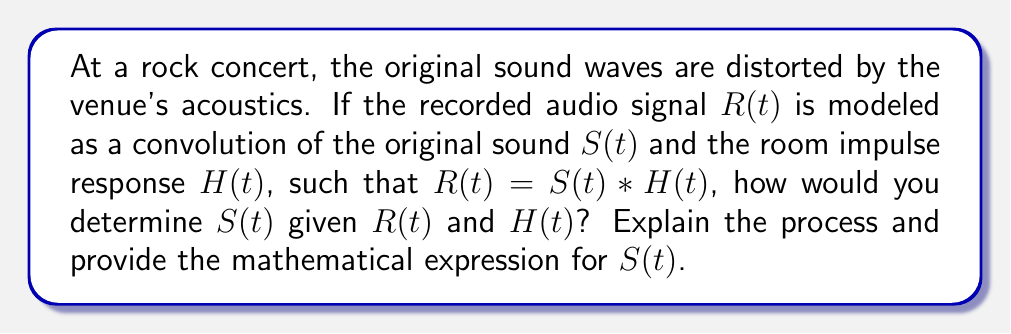Help me with this question. To determine the original sound waves $S(t)$ from the recorded audio $R(t)$ and the known room impulse response $H(t)$, we need to perform deconvolution. This is a classic inverse problem in audio processing. Here's a step-by-step approach:

1. First, recall that convolution in the time domain is equivalent to multiplication in the frequency domain. Let's apply the Fourier Transform to both sides of the equation:

   $$\mathcal{F}\{R(t)\} = \mathcal{F}\{S(t) * H(t)\} = \mathcal{F}\{S(t)\} \cdot \mathcal{F}\{H(t)\}$$

2. Let's denote the Fourier Transforms as:
   
   $$R(\omega) = S(\omega) \cdot H(\omega)$$

   where $\omega$ represents frequency.

3. To isolate $S(\omega)$, we can divide both sides by $H(\omega)$:

   $$S(\omega) = \frac{R(\omega)}{H(\omega)}$$

4. However, this direct division can lead to instabilities if $H(\omega)$ is close to zero at any frequencies. To mitigate this, we can use regularization techniques such as the Wiener deconvolution:

   $$S(\omega) = \frac{H^*(\omega)R(\omega)}{|H(\omega)|^2 + \epsilon}$$

   where $H^*(\omega)$ is the complex conjugate of $H(\omega)$, and $\epsilon$ is a small positive constant to prevent division by zero.

5. Finally, to obtain $S(t)$, we apply the inverse Fourier Transform:

   $$S(t) = \mathcal{F}^{-1}\{S(\omega)\}$$

This process allows us to recover the original sound waves while accounting for potential noise and instabilities in the deconvolution process.
Answer: $$S(t) = \mathcal{F}^{-1}\left\{\frac{H^*(\omega)R(\omega)}{|H(\omega)|^2 + \epsilon}\right\}$$ 